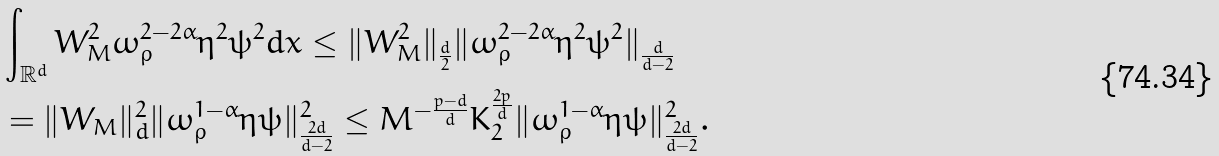<formula> <loc_0><loc_0><loc_500><loc_500>& \int _ { \mathbb { R } ^ { d } } W _ { M } ^ { 2 } \omega _ { \varrho } ^ { 2 - 2 \alpha } \eta ^ { 2 } \psi ^ { 2 } d x \leq \| W _ { M } ^ { 2 } \| _ { \frac { d } { 2 } } \| \omega _ { \varrho } ^ { 2 - 2 \alpha } \eta ^ { 2 } \psi ^ { 2 } \| _ { \frac { d } { d - 2 } } \\ & = \| W _ { M } \| _ { d } ^ { 2 } \| \omega _ { \varrho } ^ { 1 - \alpha } \eta \psi \| _ { \frac { 2 d } { d - 2 } } ^ { 2 } \leq M ^ { - \frac { p - d } { d } } K _ { 2 } ^ { \frac { 2 p } { d } } \| \omega _ { \varrho } ^ { 1 - \alpha } \eta \psi \| _ { \frac { 2 d } { d - 2 } } ^ { 2 } .</formula> 